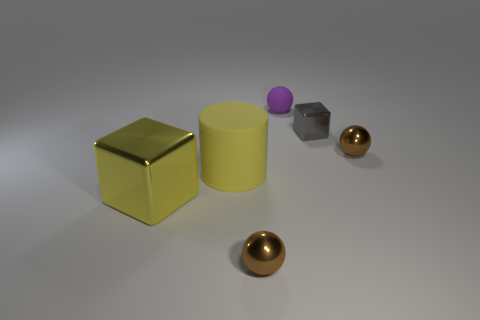Are there any other things that have the same shape as the yellow matte object?
Provide a succinct answer. No. What color is the metallic cube right of the big yellow cube?
Offer a terse response. Gray. What size is the brown shiny object right of the tiny brown ball in front of the big yellow cylinder?
Your answer should be compact. Small. Does the big object to the right of the yellow metallic thing have the same shape as the yellow metal thing?
Offer a terse response. No. There is a big thing that is the same shape as the tiny gray object; what is it made of?
Your answer should be compact. Metal. What number of objects are either tiny metal things right of the small purple rubber ball or balls that are behind the yellow cube?
Ensure brevity in your answer.  3. There is a large cylinder; is its color the same as the thing that is left of the big matte cylinder?
Your answer should be very brief. Yes. What is the shape of the big yellow object that is made of the same material as the purple sphere?
Offer a very short reply. Cylinder. What number of small shiny things are there?
Your answer should be compact. 3. How many things are either cubes behind the big rubber object or tiny metal balls?
Offer a very short reply. 3. 